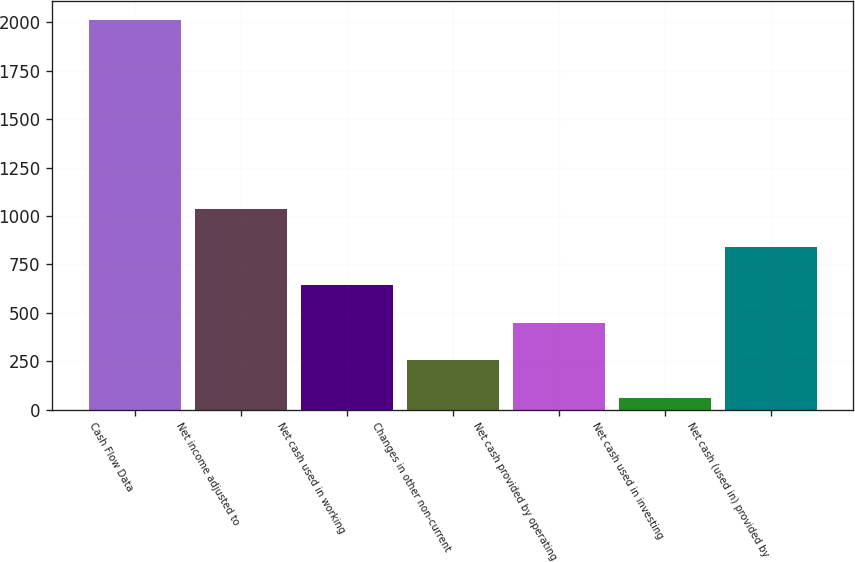Convert chart to OTSL. <chart><loc_0><loc_0><loc_500><loc_500><bar_chart><fcel>Cash Flow Data<fcel>Net income adjusted to<fcel>Net cash used in working<fcel>Changes in other non-current<fcel>Net cash provided by operating<fcel>Net cash used in investing<fcel>Net cash (used in) provided by<nl><fcel>2011<fcel>1034.9<fcel>644.46<fcel>254.02<fcel>449.24<fcel>58.8<fcel>839.68<nl></chart> 